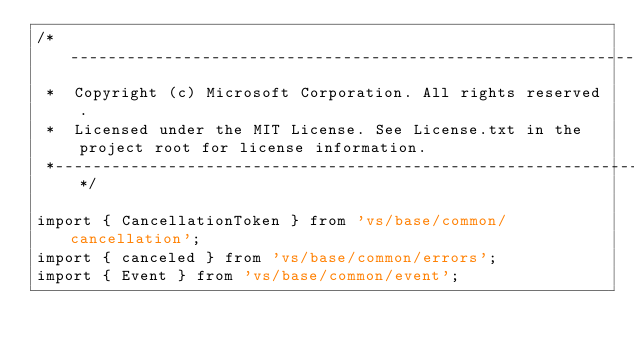<code> <loc_0><loc_0><loc_500><loc_500><_TypeScript_>/*---------------------------------------------------------------------------------------------
 *  Copyright (c) Microsoft Corporation. All rights reserved.
 *  Licensed under the MIT License. See License.txt in the project root for license information.
 *--------------------------------------------------------------------------------------------*/

import { CancellationToken } from 'vs/base/common/cancellation';
import { canceled } from 'vs/base/common/errors';
import { Event } from 'vs/base/common/event';</code> 